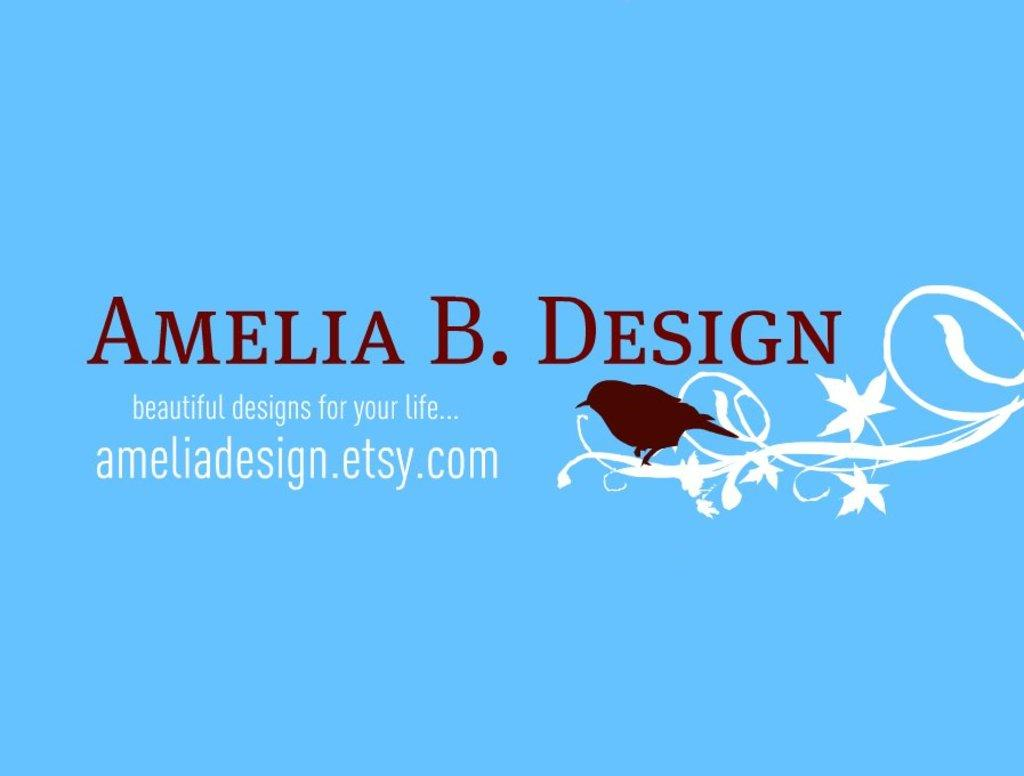What is the main subject in the center of the image? There is a poster in the center of the image. What design is featured on the poster? The poster has a design with a bird. What else can be found on the poster besides the bird design? There is text on the poster. What substance is being used to illuminate the poster in the image? There is no substance being used to illuminate the poster in the image. What is the purpose of the lamp in the image? There is no lamp present in the image. 